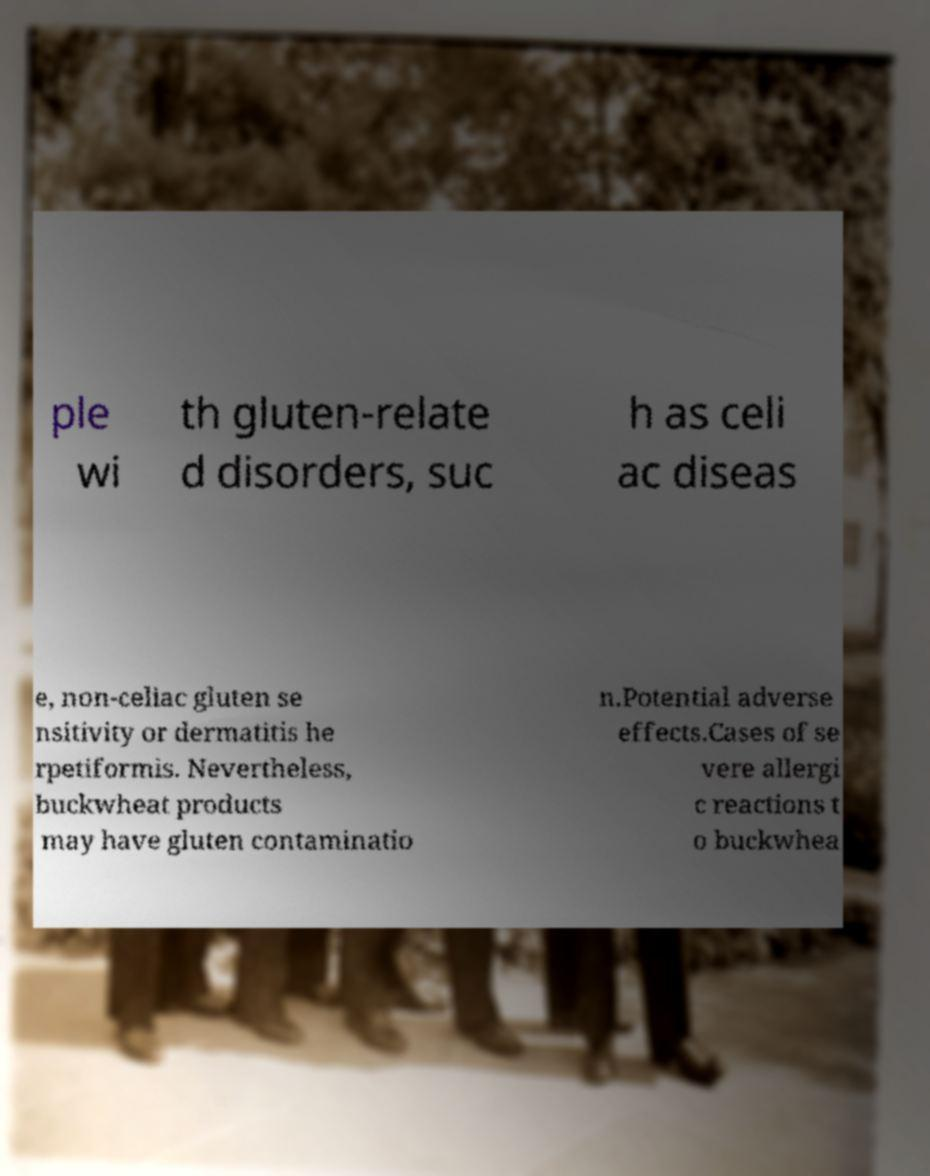For documentation purposes, I need the text within this image transcribed. Could you provide that? ple wi th gluten-relate d disorders, suc h as celi ac diseas e, non-celiac gluten se nsitivity or dermatitis he rpetiformis. Nevertheless, buckwheat products may have gluten contaminatio n.Potential adverse effects.Cases of se vere allergi c reactions t o buckwhea 